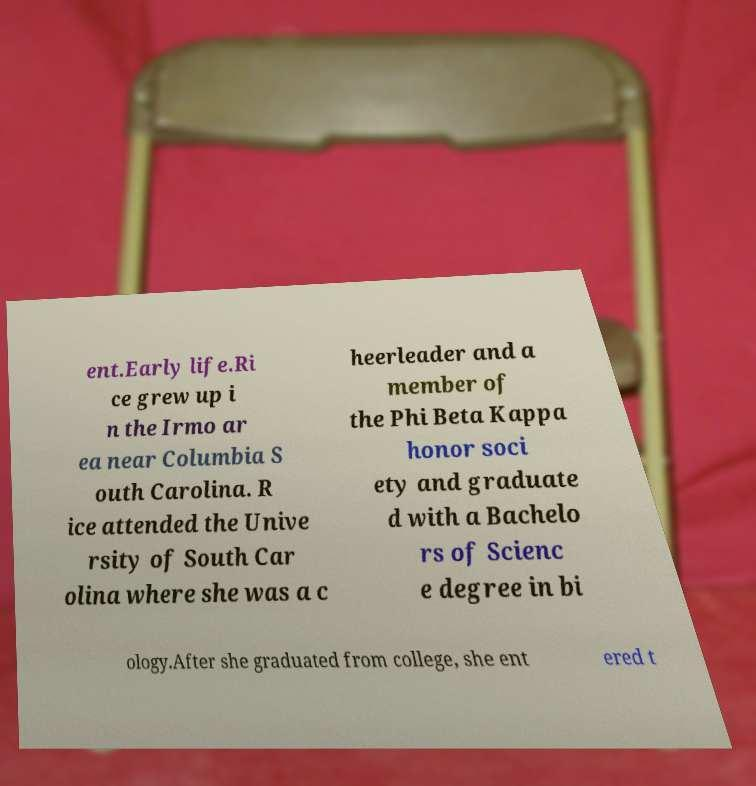I need the written content from this picture converted into text. Can you do that? ent.Early life.Ri ce grew up i n the Irmo ar ea near Columbia S outh Carolina. R ice attended the Unive rsity of South Car olina where she was a c heerleader and a member of the Phi Beta Kappa honor soci ety and graduate d with a Bachelo rs of Scienc e degree in bi ology.After she graduated from college, she ent ered t 